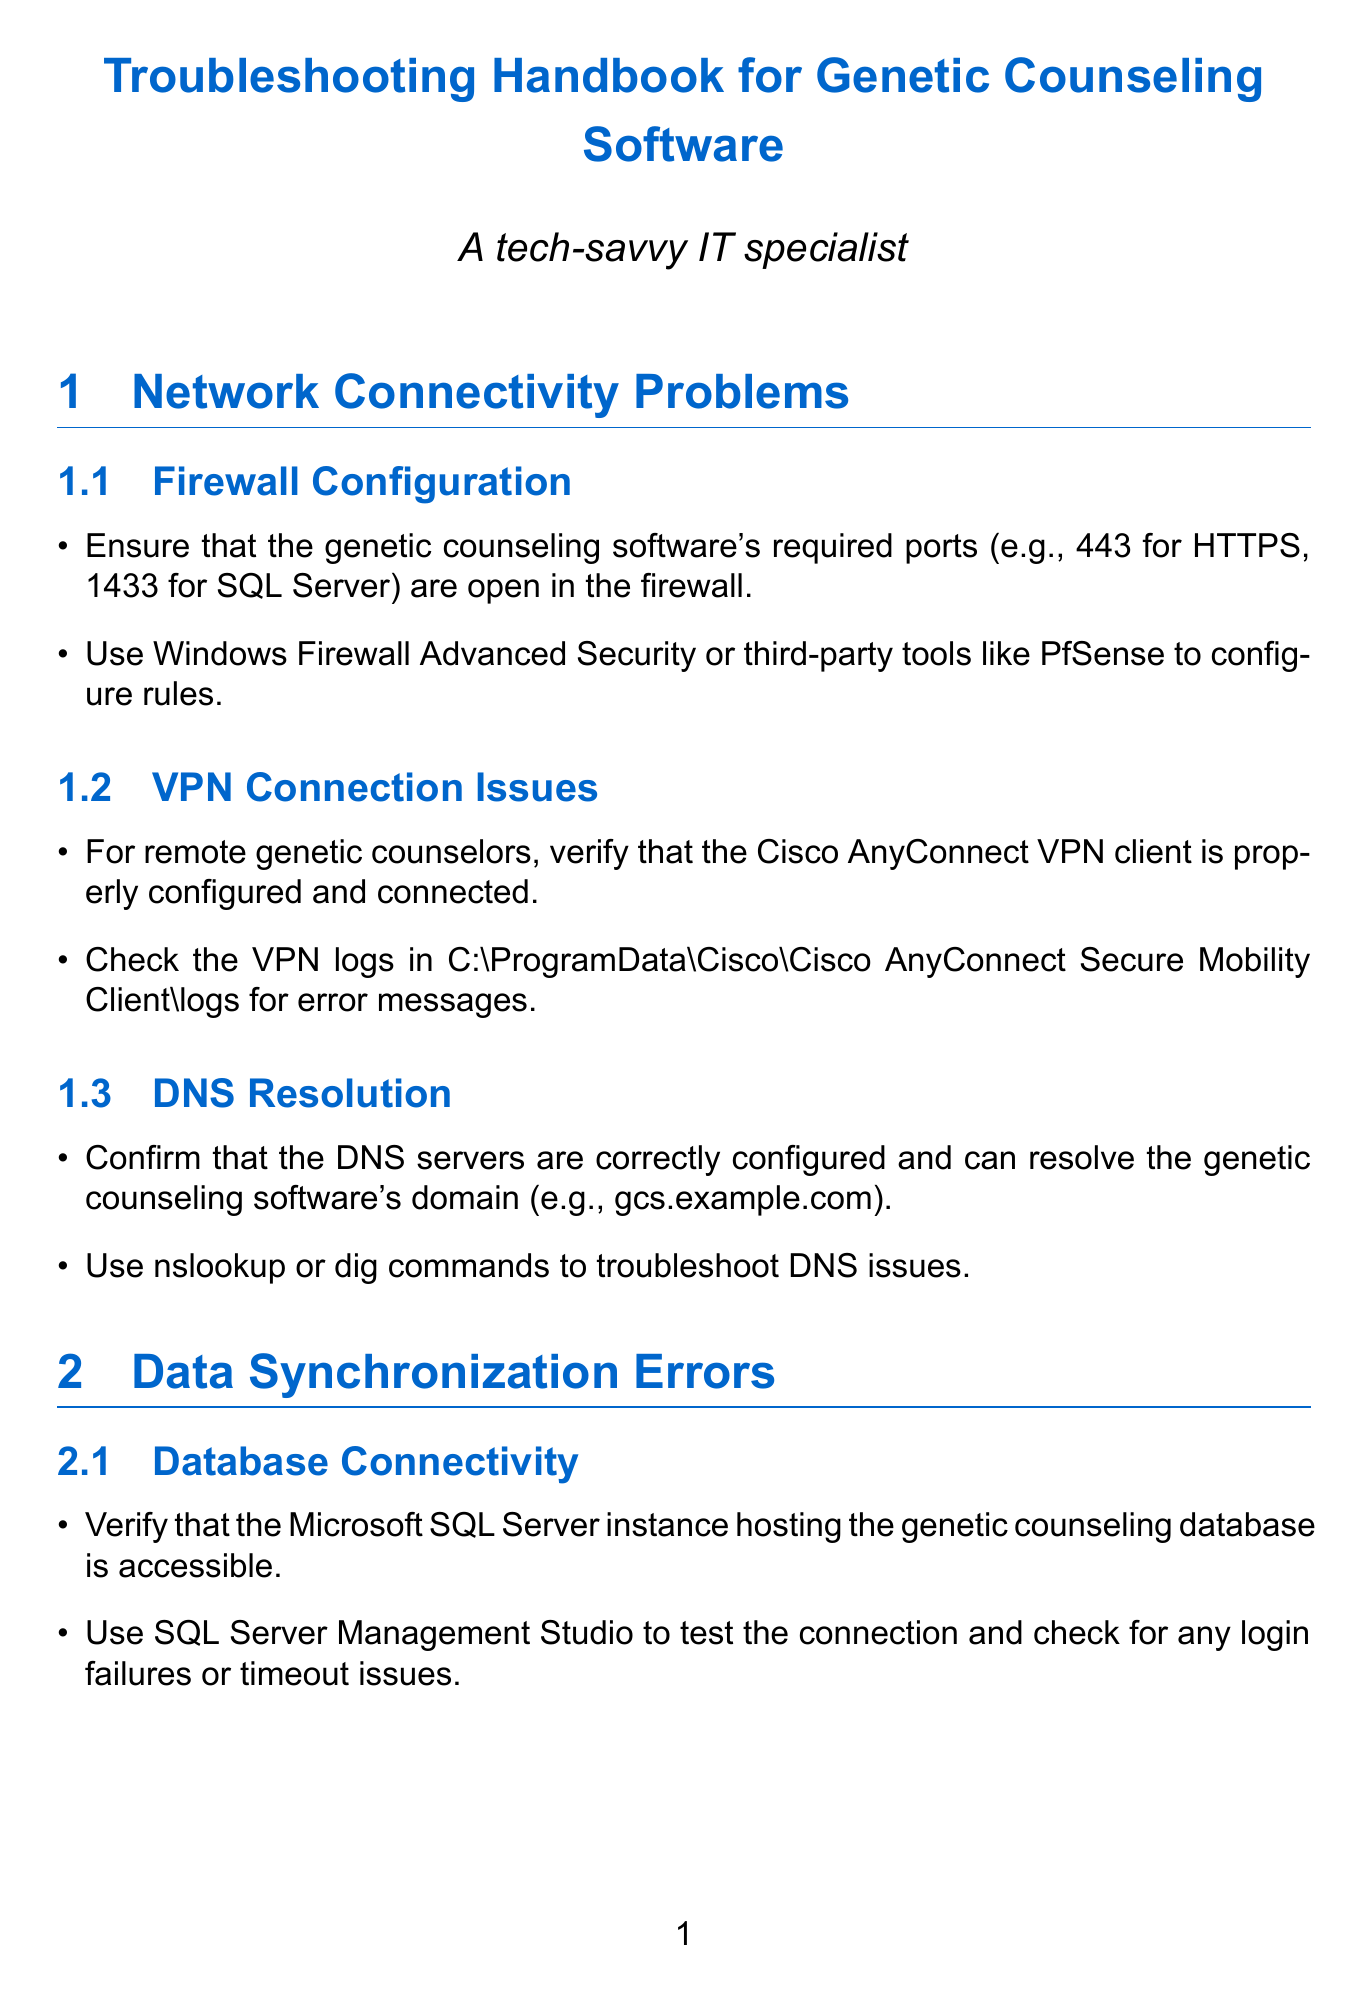What is the recommended SQL Server port? The document specifies that the required port for SQL Server is 1433.
Answer: 1433 Where should you check for VPN logs? The manual states that VPN logs can be found in a specific directory on the system.
Answer: C:\ProgramData\Cisco\Cisco AnyConnect Secure Mobility Client\logs What is the minimum RAM requirement for GenomeSuite? The document mentions the hardware requirements for the software, particularly the RAM needed.
Answer: 16GB What encryption algorithm is recommended for sensitive genetic data? The document advises using a strong encryption algorithm for data encryption.
Answer: AES-256 What tool is suggested for reviewing synchronization logs? The manual indicates a location for the sync logs and advises on their review for error messages.
Answer: C:\ProgramFiles\GeneticCounselingApp\logs\sync.log What is the role of the SQL Server Profiler mentioned in the document? The document states that SQL Server Profiler helps in identifying slow-running queries for performance optimization.
Answer: Identify slow-running queries What Windows version is required for GeneticApp v3.2? The document specifies the Windows version requirement for compatibility with the software.
Answer: Windows 10 (build 1909) or later What compliance regulations must the genetic counseling software adhere to? The document notes the importance of compliance and mentions specific regulations.
Answer: HIPAA What feature should be implemented for user account management? The document highlights the importance of managing user permissions through a specific method.
Answer: Role-based access control 